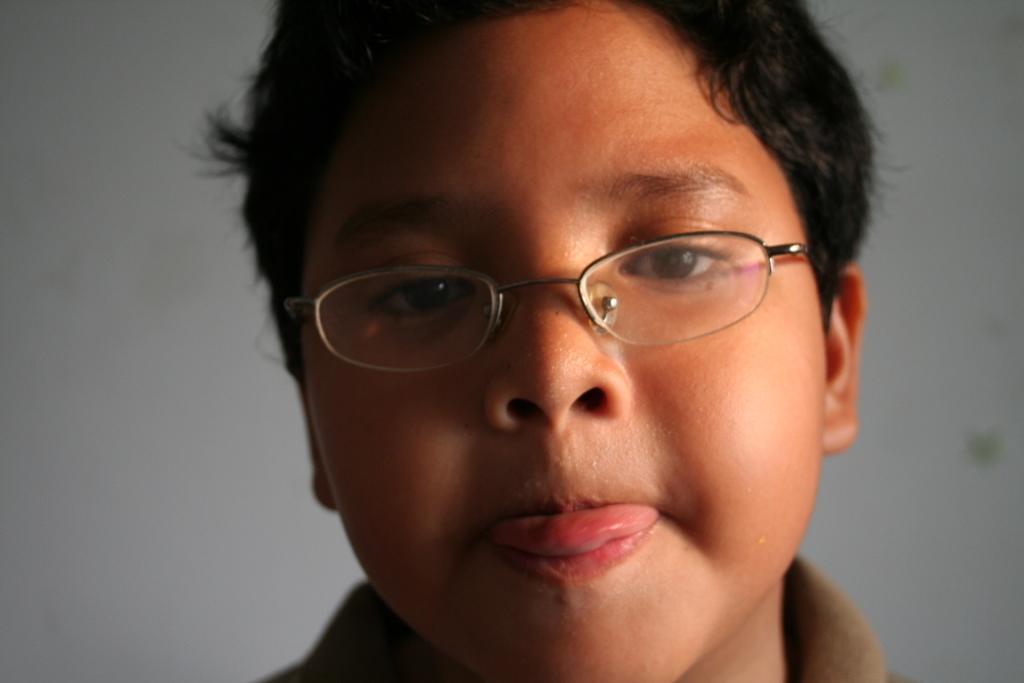In one or two sentences, can you explain what this image depicts? In this image we can see a boy and the boy is wearing spectacles. In the background, we can see a wall. 